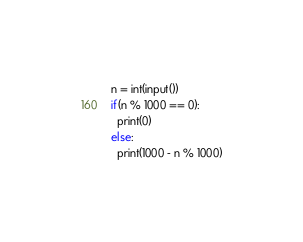<code> <loc_0><loc_0><loc_500><loc_500><_Python_>n = int(input())
if(n % 1000 == 0):
  print(0)
else:
  print(1000 - n % 1000)</code> 